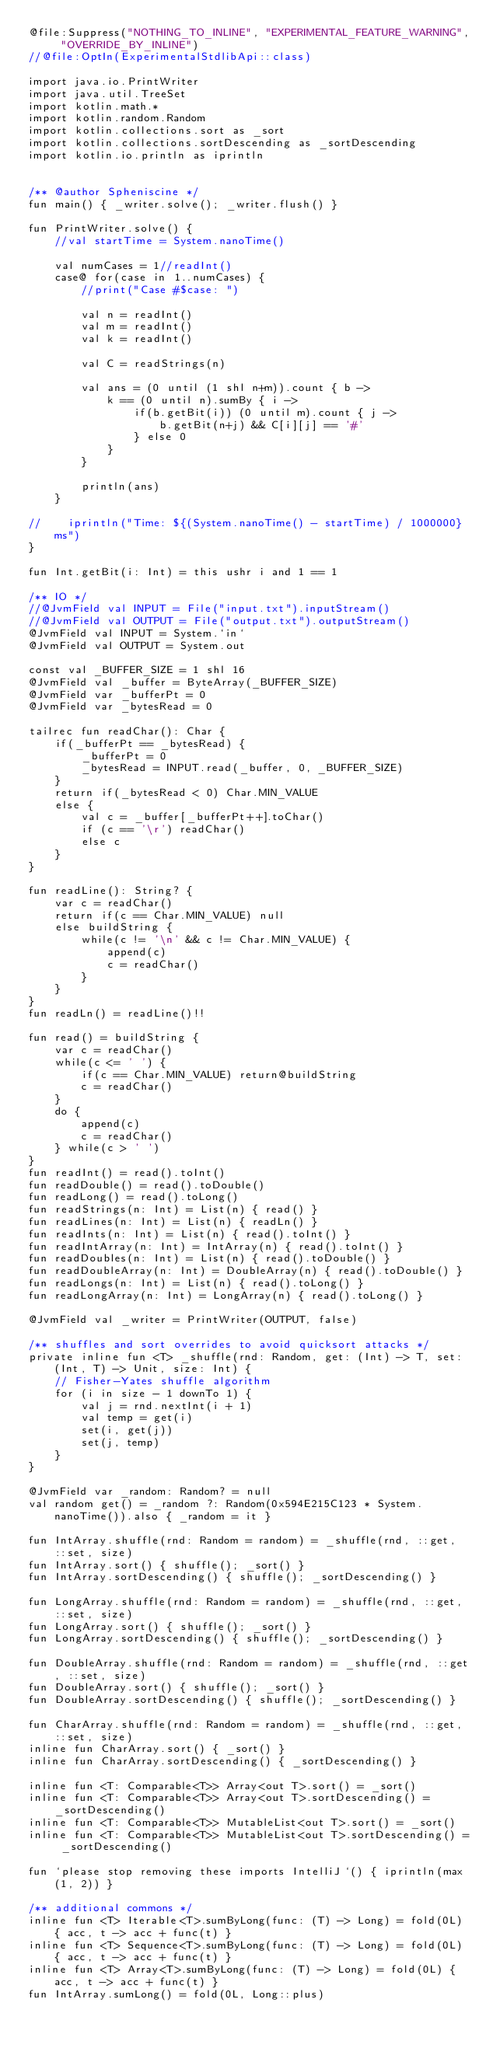<code> <loc_0><loc_0><loc_500><loc_500><_Kotlin_>@file:Suppress("NOTHING_TO_INLINE", "EXPERIMENTAL_FEATURE_WARNING", "OVERRIDE_BY_INLINE")
//@file:OptIn(ExperimentalStdlibApi::class)

import java.io.PrintWriter
import java.util.TreeSet
import kotlin.math.*
import kotlin.random.Random
import kotlin.collections.sort as _sort
import kotlin.collections.sortDescending as _sortDescending
import kotlin.io.println as iprintln


/** @author Spheniscine */
fun main() { _writer.solve(); _writer.flush() }

fun PrintWriter.solve() {
    //val startTime = System.nanoTime()

    val numCases = 1//readInt()
    case@ for(case in 1..numCases) {
        //print("Case #$case: ")

        val n = readInt()
        val m = readInt()
        val k = readInt()

        val C = readStrings(n)

        val ans = (0 until (1 shl n+m)).count { b ->
            k == (0 until n).sumBy { i ->
                if(b.getBit(i)) (0 until m).count { j ->
                    b.getBit(n+j) && C[i][j] == '#'
                } else 0
            }
        }

        println(ans)
    }

//    iprintln("Time: ${(System.nanoTime() - startTime) / 1000000} ms")
}

fun Int.getBit(i: Int) = this ushr i and 1 == 1

/** IO */
//@JvmField val INPUT = File("input.txt").inputStream()
//@JvmField val OUTPUT = File("output.txt").outputStream()
@JvmField val INPUT = System.`in`
@JvmField val OUTPUT = System.out

const val _BUFFER_SIZE = 1 shl 16
@JvmField val _buffer = ByteArray(_BUFFER_SIZE)
@JvmField var _bufferPt = 0
@JvmField var _bytesRead = 0

tailrec fun readChar(): Char {
    if(_bufferPt == _bytesRead) {
        _bufferPt = 0
        _bytesRead = INPUT.read(_buffer, 0, _BUFFER_SIZE)
    }
    return if(_bytesRead < 0) Char.MIN_VALUE
    else {
        val c = _buffer[_bufferPt++].toChar()
        if (c == '\r') readChar()
        else c
    }
}

fun readLine(): String? {
    var c = readChar()
    return if(c == Char.MIN_VALUE) null
    else buildString {
        while(c != '\n' && c != Char.MIN_VALUE) {
            append(c)
            c = readChar()
        }
    }
}
fun readLn() = readLine()!!

fun read() = buildString {
    var c = readChar()
    while(c <= ' ') {
        if(c == Char.MIN_VALUE) return@buildString
        c = readChar()
    }
    do {
        append(c)
        c = readChar()
    } while(c > ' ')
}
fun readInt() = read().toInt()
fun readDouble() = read().toDouble()
fun readLong() = read().toLong()
fun readStrings(n: Int) = List(n) { read() }
fun readLines(n: Int) = List(n) { readLn() }
fun readInts(n: Int) = List(n) { read().toInt() }
fun readIntArray(n: Int) = IntArray(n) { read().toInt() }
fun readDoubles(n: Int) = List(n) { read().toDouble() }
fun readDoubleArray(n: Int) = DoubleArray(n) { read().toDouble() }
fun readLongs(n: Int) = List(n) { read().toLong() }
fun readLongArray(n: Int) = LongArray(n) { read().toLong() }

@JvmField val _writer = PrintWriter(OUTPUT, false)

/** shuffles and sort overrides to avoid quicksort attacks */
private inline fun <T> _shuffle(rnd: Random, get: (Int) -> T, set: (Int, T) -> Unit, size: Int) {
    // Fisher-Yates shuffle algorithm
    for (i in size - 1 downTo 1) {
        val j = rnd.nextInt(i + 1)
        val temp = get(i)
        set(i, get(j))
        set(j, temp)
    }
}

@JvmField var _random: Random? = null
val random get() = _random ?: Random(0x594E215C123 * System.nanoTime()).also { _random = it }

fun IntArray.shuffle(rnd: Random = random) = _shuffle(rnd, ::get, ::set, size)
fun IntArray.sort() { shuffle(); _sort() }
fun IntArray.sortDescending() { shuffle(); _sortDescending() }

fun LongArray.shuffle(rnd: Random = random) = _shuffle(rnd, ::get, ::set, size)
fun LongArray.sort() { shuffle(); _sort() }
fun LongArray.sortDescending() { shuffle(); _sortDescending() }

fun DoubleArray.shuffle(rnd: Random = random) = _shuffle(rnd, ::get, ::set, size)
fun DoubleArray.sort() { shuffle(); _sort() }
fun DoubleArray.sortDescending() { shuffle(); _sortDescending() }

fun CharArray.shuffle(rnd: Random = random) = _shuffle(rnd, ::get, ::set, size)
inline fun CharArray.sort() { _sort() }
inline fun CharArray.sortDescending() { _sortDescending() }

inline fun <T: Comparable<T>> Array<out T>.sort() = _sort()
inline fun <T: Comparable<T>> Array<out T>.sortDescending() = _sortDescending()
inline fun <T: Comparable<T>> MutableList<out T>.sort() = _sort()
inline fun <T: Comparable<T>> MutableList<out T>.sortDescending() = _sortDescending()

fun `please stop removing these imports IntelliJ`() { iprintln(max(1, 2)) }

/** additional commons */
inline fun <T> Iterable<T>.sumByLong(func: (T) -> Long) = fold(0L) { acc, t -> acc + func(t) }
inline fun <T> Sequence<T>.sumByLong(func: (T) -> Long) = fold(0L) { acc, t -> acc + func(t) }
inline fun <T> Array<T>.sumByLong(func: (T) -> Long) = fold(0L) { acc, t -> acc + func(t) }
fun IntArray.sumLong() = fold(0L, Long::plus)
</code> 